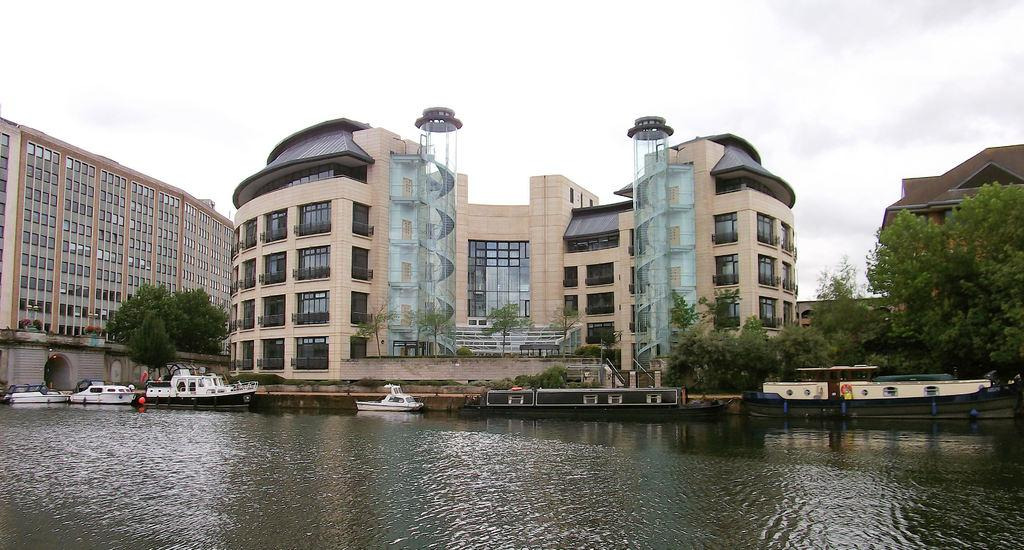What type of structures can be seen in the image? There are buildings in the image. What feature is visible on the buildings? There are windows visible in the image. What is located near the buildings? There are boats on a river in the image. What type of vegetation is present in the image? Trees are present in the image. What part of the natural environment is visible in the image? The sky is visible in the image. What architectural element can be seen in the image? There is a wall in the image. What type of cherries can be seen growing on the wall in the image? There are no cherries present in the image, and the wall does not have any plants growing on it. Can you tell me how the profession of the person resting on the boat in the image? There is no person resting on the boat in the image, and we cannot determine their profession from the information provided. 